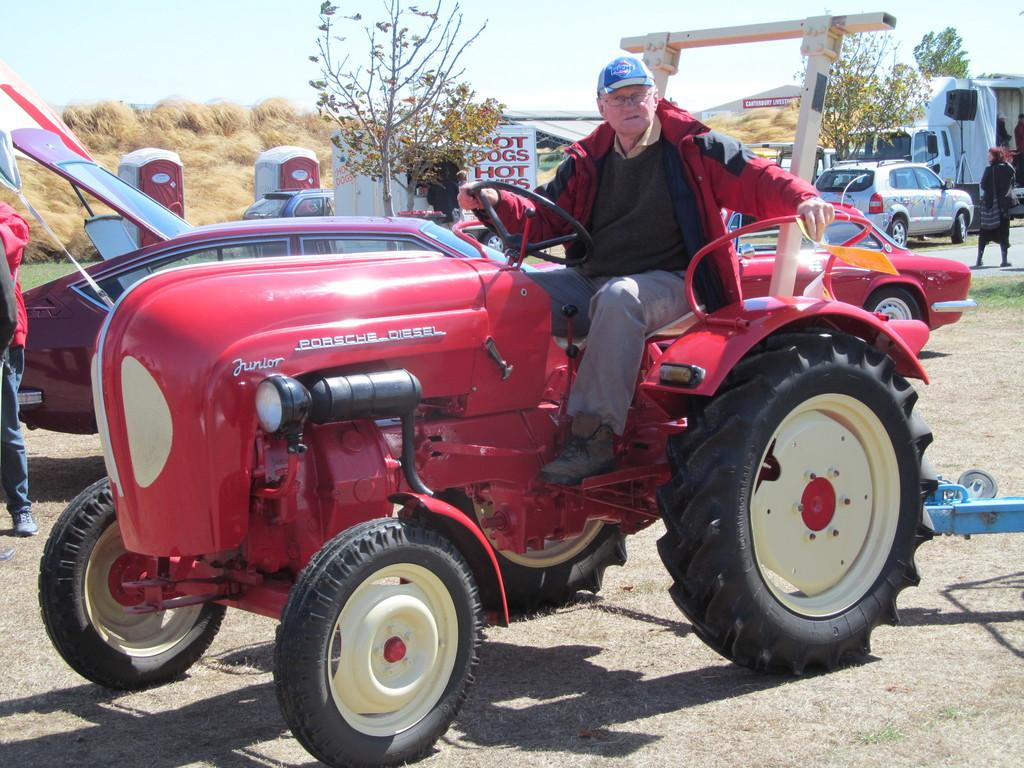Who is present in the image? There is a man in the image. What is the man doing in the image? The man is sitting on a vehicle. Are there any other vehicles in the image? Yes, there are other vehicles around the man. What can be seen in the background of the image? There is a lot of grass in the background of the image. What type of knowledge does the man possess about the heart in the image? There is no indication in the image that the man possesses any knowledge about the heart or that the heart is even present in the image. 